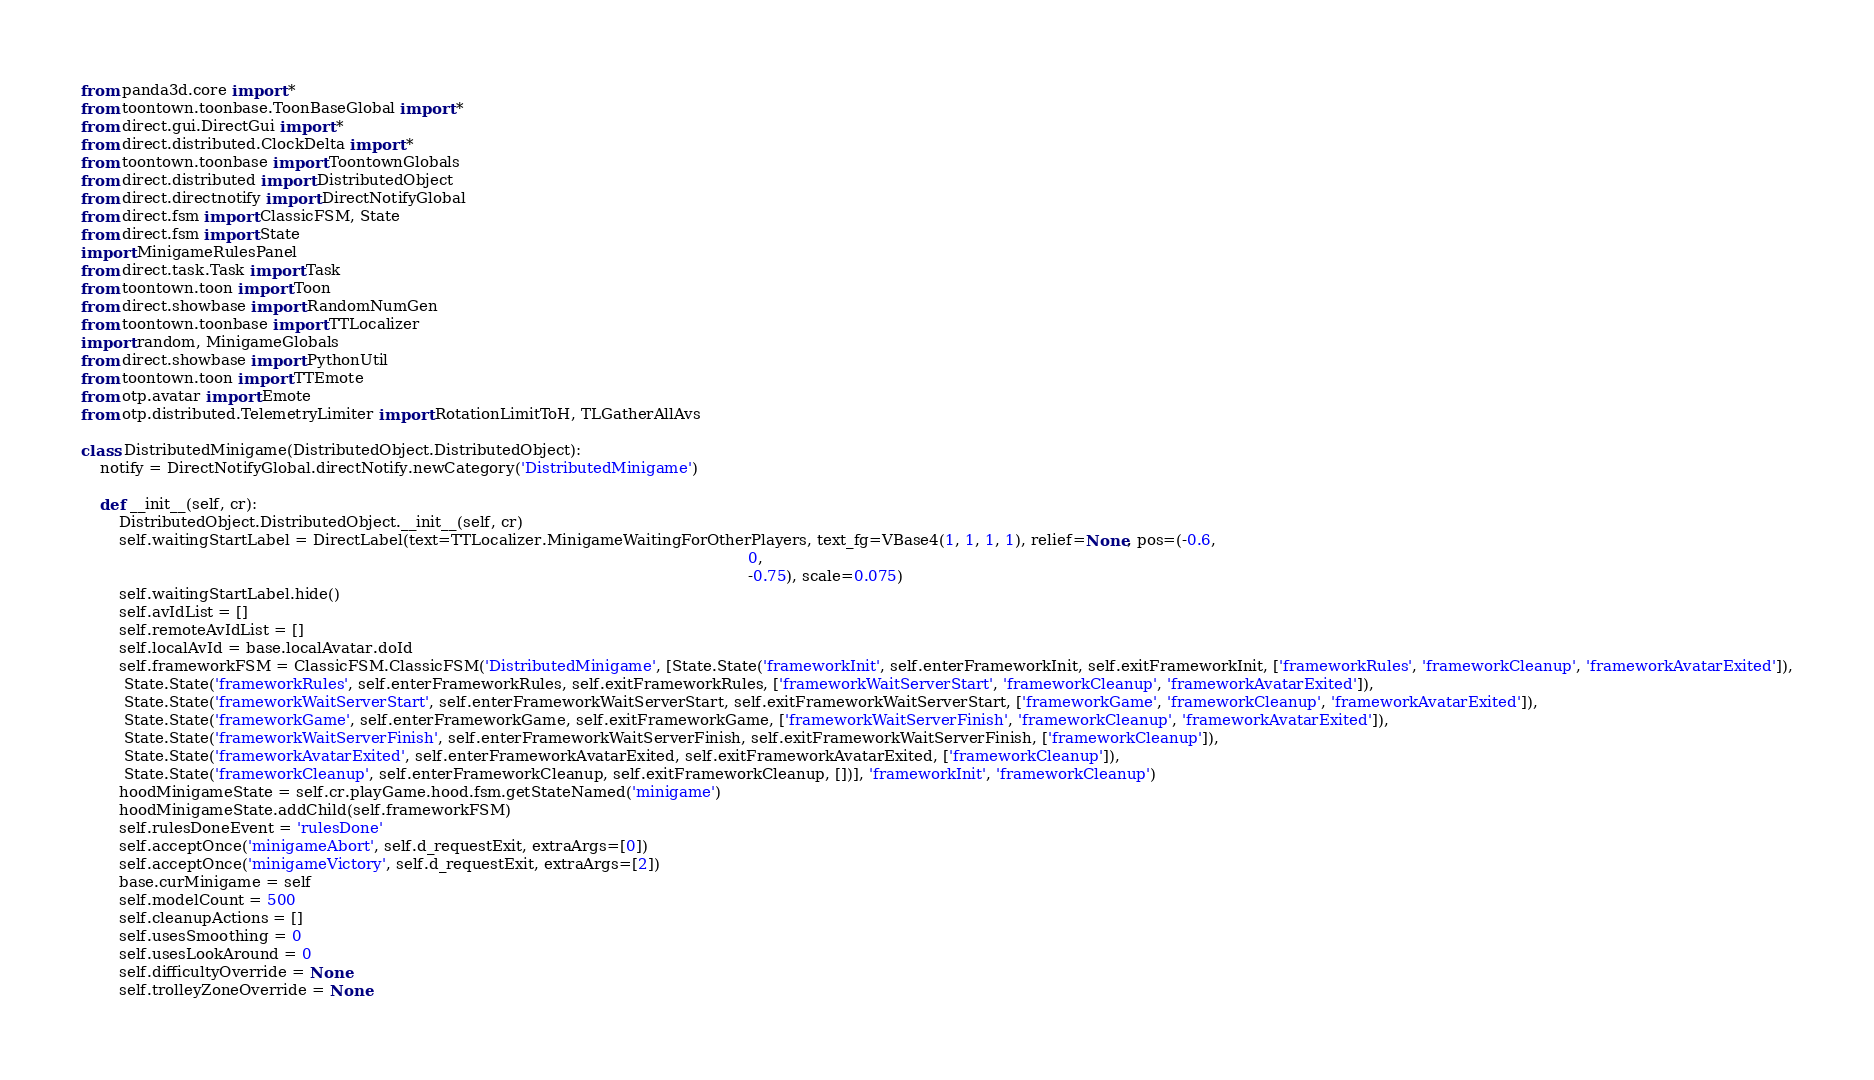<code> <loc_0><loc_0><loc_500><loc_500><_Python_>from panda3d.core import *
from toontown.toonbase.ToonBaseGlobal import *
from direct.gui.DirectGui import *
from direct.distributed.ClockDelta import *
from toontown.toonbase import ToontownGlobals
from direct.distributed import DistributedObject
from direct.directnotify import DirectNotifyGlobal
from direct.fsm import ClassicFSM, State
from direct.fsm import State
import MinigameRulesPanel
from direct.task.Task import Task
from toontown.toon import Toon
from direct.showbase import RandomNumGen
from toontown.toonbase import TTLocalizer
import random, MinigameGlobals
from direct.showbase import PythonUtil
from toontown.toon import TTEmote
from otp.avatar import Emote
from otp.distributed.TelemetryLimiter import RotationLimitToH, TLGatherAllAvs

class DistributedMinigame(DistributedObject.DistributedObject):
    notify = DirectNotifyGlobal.directNotify.newCategory('DistributedMinigame')

    def __init__(self, cr):
        DistributedObject.DistributedObject.__init__(self, cr)
        self.waitingStartLabel = DirectLabel(text=TTLocalizer.MinigameWaitingForOtherPlayers, text_fg=VBase4(1, 1, 1, 1), relief=None, pos=(-0.6,
                                                                                                                                            0,
                                                                                                                                            -0.75), scale=0.075)
        self.waitingStartLabel.hide()
        self.avIdList = []
        self.remoteAvIdList = []
        self.localAvId = base.localAvatar.doId
        self.frameworkFSM = ClassicFSM.ClassicFSM('DistributedMinigame', [State.State('frameworkInit', self.enterFrameworkInit, self.exitFrameworkInit, ['frameworkRules', 'frameworkCleanup', 'frameworkAvatarExited']),
         State.State('frameworkRules', self.enterFrameworkRules, self.exitFrameworkRules, ['frameworkWaitServerStart', 'frameworkCleanup', 'frameworkAvatarExited']),
         State.State('frameworkWaitServerStart', self.enterFrameworkWaitServerStart, self.exitFrameworkWaitServerStart, ['frameworkGame', 'frameworkCleanup', 'frameworkAvatarExited']),
         State.State('frameworkGame', self.enterFrameworkGame, self.exitFrameworkGame, ['frameworkWaitServerFinish', 'frameworkCleanup', 'frameworkAvatarExited']),
         State.State('frameworkWaitServerFinish', self.enterFrameworkWaitServerFinish, self.exitFrameworkWaitServerFinish, ['frameworkCleanup']),
         State.State('frameworkAvatarExited', self.enterFrameworkAvatarExited, self.exitFrameworkAvatarExited, ['frameworkCleanup']),
         State.State('frameworkCleanup', self.enterFrameworkCleanup, self.exitFrameworkCleanup, [])], 'frameworkInit', 'frameworkCleanup')
        hoodMinigameState = self.cr.playGame.hood.fsm.getStateNamed('minigame')
        hoodMinigameState.addChild(self.frameworkFSM)
        self.rulesDoneEvent = 'rulesDone'
        self.acceptOnce('minigameAbort', self.d_requestExit, extraArgs=[0])
        self.acceptOnce('minigameVictory', self.d_requestExit, extraArgs=[2])
        base.curMinigame = self
        self.modelCount = 500
        self.cleanupActions = []
        self.usesSmoothing = 0
        self.usesLookAround = 0
        self.difficultyOverride = None
        self.trolleyZoneOverride = None</code> 